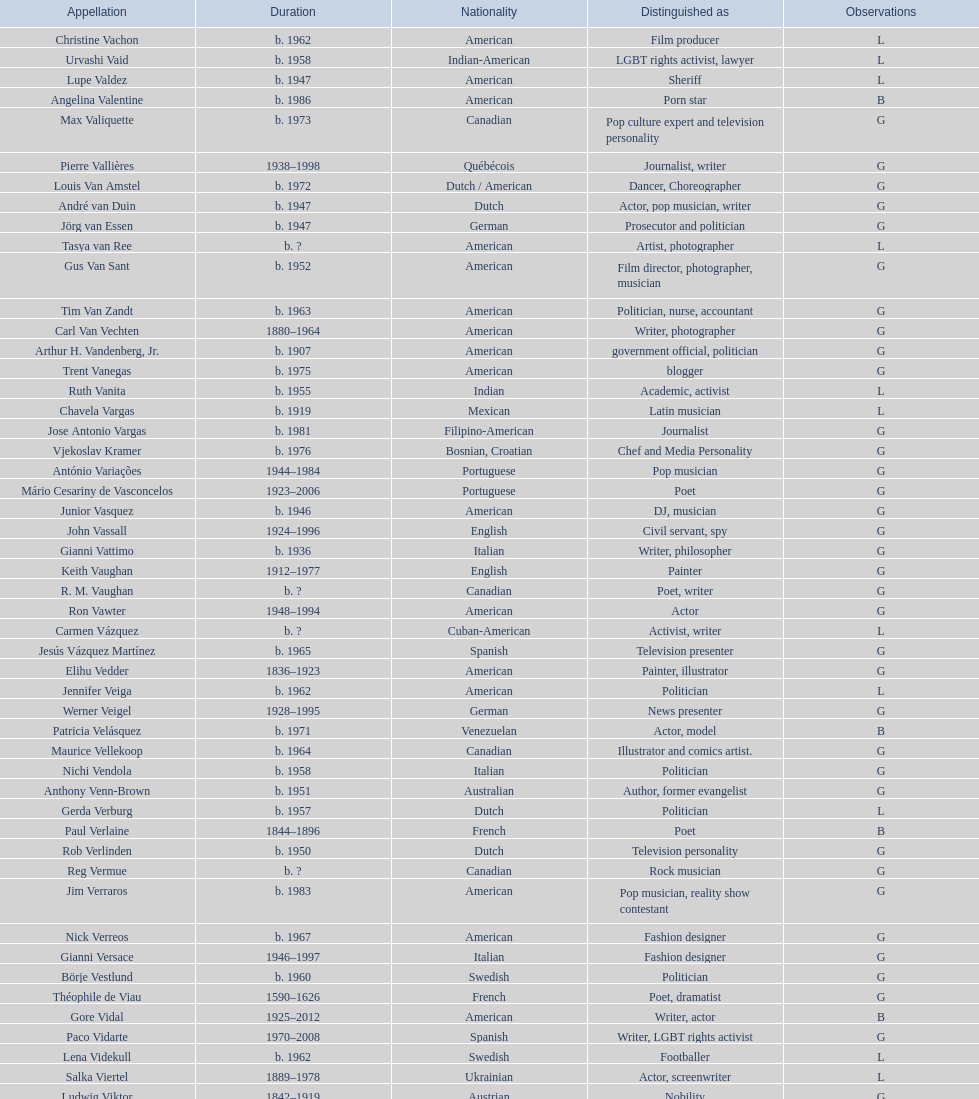Which nationality had the larger amount of names listed? American. Help me parse the entirety of this table. {'header': ['Appellation', 'Duration', 'Nationality', 'Distinguished as', 'Observations'], 'rows': [['Christine Vachon', 'b. 1962', 'American', 'Film producer', 'L'], ['Urvashi Vaid', 'b. 1958', 'Indian-American', 'LGBT rights activist, lawyer', 'L'], ['Lupe Valdez', 'b. 1947', 'American', 'Sheriff', 'L'], ['Angelina Valentine', 'b. 1986', 'American', 'Porn star', 'B'], ['Max Valiquette', 'b. 1973', 'Canadian', 'Pop culture expert and television personality', 'G'], ['Pierre Vallières', '1938–1998', 'Québécois', 'Journalist, writer', 'G'], ['Louis Van Amstel', 'b. 1972', 'Dutch / American', 'Dancer, Choreographer', 'G'], ['André van Duin', 'b. 1947', 'Dutch', 'Actor, pop musician, writer', 'G'], ['Jörg van Essen', 'b. 1947', 'German', 'Prosecutor and politician', 'G'], ['Tasya van Ree', 'b.\xa0?', 'American', 'Artist, photographer', 'L'], ['Gus Van Sant', 'b. 1952', 'American', 'Film director, photographer, musician', 'G'], ['Tim Van Zandt', 'b. 1963', 'American', 'Politician, nurse, accountant', 'G'], ['Carl Van Vechten', '1880–1964', 'American', 'Writer, photographer', 'G'], ['Arthur H. Vandenberg, Jr.', 'b. 1907', 'American', 'government official, politician', 'G'], ['Trent Vanegas', 'b. 1975', 'American', 'blogger', 'G'], ['Ruth Vanita', 'b. 1955', 'Indian', 'Academic, activist', 'L'], ['Chavela Vargas', 'b. 1919', 'Mexican', 'Latin musician', 'L'], ['Jose Antonio Vargas', 'b. 1981', 'Filipino-American', 'Journalist', 'G'], ['Vjekoslav Kramer', 'b. 1976', 'Bosnian, Croatian', 'Chef and Media Personality', 'G'], ['António Variações', '1944–1984', 'Portuguese', 'Pop musician', 'G'], ['Mário Cesariny de Vasconcelos', '1923–2006', 'Portuguese', 'Poet', 'G'], ['Junior Vasquez', 'b. 1946', 'American', 'DJ, musician', 'G'], ['John Vassall', '1924–1996', 'English', 'Civil servant, spy', 'G'], ['Gianni Vattimo', 'b. 1936', 'Italian', 'Writer, philosopher', 'G'], ['Keith Vaughan', '1912–1977', 'English', 'Painter', 'G'], ['R. M. Vaughan', 'b.\xa0?', 'Canadian', 'Poet, writer', 'G'], ['Ron Vawter', '1948–1994', 'American', 'Actor', 'G'], ['Carmen Vázquez', 'b.\xa0?', 'Cuban-American', 'Activist, writer', 'L'], ['Jesús Vázquez Martínez', 'b. 1965', 'Spanish', 'Television presenter', 'G'], ['Elihu Vedder', '1836–1923', 'American', 'Painter, illustrator', 'G'], ['Jennifer Veiga', 'b. 1962', 'American', 'Politician', 'L'], ['Werner Veigel', '1928–1995', 'German', 'News presenter', 'G'], ['Patricia Velásquez', 'b. 1971', 'Venezuelan', 'Actor, model', 'B'], ['Maurice Vellekoop', 'b. 1964', 'Canadian', 'Illustrator and comics artist.', 'G'], ['Nichi Vendola', 'b. 1958', 'Italian', 'Politician', 'G'], ['Anthony Venn-Brown', 'b. 1951', 'Australian', 'Author, former evangelist', 'G'], ['Gerda Verburg', 'b. 1957', 'Dutch', 'Politician', 'L'], ['Paul Verlaine', '1844–1896', 'French', 'Poet', 'B'], ['Rob Verlinden', 'b. 1950', 'Dutch', 'Television personality', 'G'], ['Reg Vermue', 'b.\xa0?', 'Canadian', 'Rock musician', 'G'], ['Jim Verraros', 'b. 1983', 'American', 'Pop musician, reality show contestant', 'G'], ['Nick Verreos', 'b. 1967', 'American', 'Fashion designer', 'G'], ['Gianni Versace', '1946–1997', 'Italian', 'Fashion designer', 'G'], ['Börje Vestlund', 'b. 1960', 'Swedish', 'Politician', 'G'], ['Théophile de Viau', '1590–1626', 'French', 'Poet, dramatist', 'G'], ['Gore Vidal', '1925–2012', 'American', 'Writer, actor', 'B'], ['Paco Vidarte', '1970–2008', 'Spanish', 'Writer, LGBT rights activist', 'G'], ['Lena Videkull', 'b. 1962', 'Swedish', 'Footballer', 'L'], ['Salka Viertel', '1889–1978', 'Ukrainian', 'Actor, screenwriter', 'L'], ['Ludwig Viktor', '1842–1919', 'Austrian', 'Nobility', 'G'], ['Bruce Vilanch', 'b. 1948', 'American', 'Comedy writer, actor', 'G'], ['Tom Villard', '1953–1994', 'American', 'Actor', 'G'], ['José Villarrubia', 'b. 1961', 'American', 'Artist', 'G'], ['Xavier Villaurrutia', '1903–1950', 'Mexican', 'Poet, playwright', 'G'], ["Alain-Philippe Malagnac d'Argens de Villèle", '1950–2000', 'French', 'Aristocrat', 'G'], ['Norah Vincent', 'b.\xa0?', 'American', 'Journalist', 'L'], ['Donald Vining', '1917–1998', 'American', 'Writer', 'G'], ['Luchino Visconti', '1906–1976', 'Italian', 'Filmmaker', 'G'], ['Pavel Vítek', 'b. 1962', 'Czech', 'Pop musician, actor', 'G'], ['Renée Vivien', '1877–1909', 'English', 'Poet', 'L'], ['Claude Vivier', '1948–1983', 'Canadian', '20th century classical composer', 'G'], ['Taylor Vixen', 'b. 1983', 'American', 'Porn star', 'B'], ['Bruce Voeller', '1934–1994', 'American', 'HIV/AIDS researcher', 'G'], ['Paula Vogel', 'b. 1951', 'American', 'Playwright', 'L'], ['Julia Volkova', 'b. 1985', 'Russian', 'Singer', 'B'], ['Jörg van Essen', 'b. 1947', 'German', 'Politician', 'G'], ['Ole von Beust', 'b. 1955', 'German', 'Politician', 'G'], ['Wilhelm von Gloeden', '1856–1931', 'German', 'Photographer', 'G'], ['Rosa von Praunheim', 'b. 1942', 'German', 'Film director', 'G'], ['Kurt von Ruffin', 'b. 1901–1996', 'German', 'Holocaust survivor', 'G'], ['Hella von Sinnen', 'b. 1959', 'German', 'Comedian', 'L'], ['Daniel Vosovic', 'b. 1981', 'American', 'Fashion designer', 'G'], ['Delwin Vriend', 'b. 1966', 'Canadian', 'LGBT rights activist', 'G']]} 